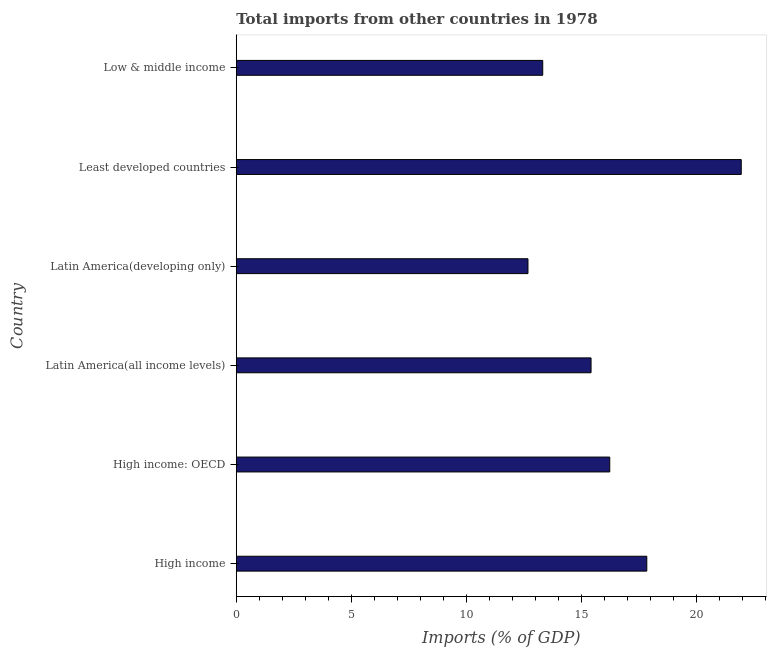Does the graph contain grids?
Offer a terse response. No. What is the title of the graph?
Offer a terse response. Total imports from other countries in 1978. What is the label or title of the X-axis?
Your answer should be very brief. Imports (% of GDP). What is the label or title of the Y-axis?
Your answer should be very brief. Country. What is the total imports in High income?
Your answer should be very brief. 17.84. Across all countries, what is the maximum total imports?
Offer a very short reply. 21.95. Across all countries, what is the minimum total imports?
Your answer should be compact. 12.68. In which country was the total imports maximum?
Make the answer very short. Least developed countries. In which country was the total imports minimum?
Give a very brief answer. Latin America(developing only). What is the sum of the total imports?
Provide a short and direct response. 97.45. What is the difference between the total imports in High income: OECD and Low & middle income?
Your answer should be very brief. 2.91. What is the average total imports per country?
Offer a very short reply. 16.24. What is the median total imports?
Offer a very short reply. 15.83. In how many countries, is the total imports greater than 13 %?
Your answer should be very brief. 5. What is the ratio of the total imports in Latin America(all income levels) to that in Latin America(developing only)?
Ensure brevity in your answer.  1.22. Is the difference between the total imports in High income: OECD and Least developed countries greater than the difference between any two countries?
Give a very brief answer. No. What is the difference between the highest and the second highest total imports?
Give a very brief answer. 4.11. What is the difference between the highest and the lowest total imports?
Keep it short and to the point. 9.27. In how many countries, is the total imports greater than the average total imports taken over all countries?
Your response must be concise. 2. How many countries are there in the graph?
Provide a succinct answer. 6. What is the Imports (% of GDP) of High income?
Offer a very short reply. 17.84. What is the Imports (% of GDP) in High income: OECD?
Provide a succinct answer. 16.23. What is the Imports (% of GDP) of Latin America(all income levels)?
Provide a succinct answer. 15.42. What is the Imports (% of GDP) in Latin America(developing only)?
Make the answer very short. 12.68. What is the Imports (% of GDP) of Least developed countries?
Keep it short and to the point. 21.95. What is the Imports (% of GDP) of Low & middle income?
Offer a terse response. 13.32. What is the difference between the Imports (% of GDP) in High income and High income: OECD?
Give a very brief answer. 1.61. What is the difference between the Imports (% of GDP) in High income and Latin America(all income levels)?
Ensure brevity in your answer.  2.42. What is the difference between the Imports (% of GDP) in High income and Latin America(developing only)?
Provide a succinct answer. 5.16. What is the difference between the Imports (% of GDP) in High income and Least developed countries?
Provide a succinct answer. -4.1. What is the difference between the Imports (% of GDP) in High income and Low & middle income?
Your answer should be very brief. 4.52. What is the difference between the Imports (% of GDP) in High income: OECD and Latin America(all income levels)?
Make the answer very short. 0.81. What is the difference between the Imports (% of GDP) in High income: OECD and Latin America(developing only)?
Provide a succinct answer. 3.55. What is the difference between the Imports (% of GDP) in High income: OECD and Least developed countries?
Your answer should be very brief. -5.72. What is the difference between the Imports (% of GDP) in High income: OECD and Low & middle income?
Ensure brevity in your answer.  2.91. What is the difference between the Imports (% of GDP) in Latin America(all income levels) and Latin America(developing only)?
Your answer should be compact. 2.74. What is the difference between the Imports (% of GDP) in Latin America(all income levels) and Least developed countries?
Offer a terse response. -6.53. What is the difference between the Imports (% of GDP) in Latin America(all income levels) and Low & middle income?
Your answer should be very brief. 2.1. What is the difference between the Imports (% of GDP) in Latin America(developing only) and Least developed countries?
Offer a very short reply. -9.27. What is the difference between the Imports (% of GDP) in Latin America(developing only) and Low & middle income?
Provide a short and direct response. -0.64. What is the difference between the Imports (% of GDP) in Least developed countries and Low & middle income?
Ensure brevity in your answer.  8.63. What is the ratio of the Imports (% of GDP) in High income to that in High income: OECD?
Keep it short and to the point. 1.1. What is the ratio of the Imports (% of GDP) in High income to that in Latin America(all income levels)?
Your response must be concise. 1.16. What is the ratio of the Imports (% of GDP) in High income to that in Latin America(developing only)?
Provide a succinct answer. 1.41. What is the ratio of the Imports (% of GDP) in High income to that in Least developed countries?
Provide a short and direct response. 0.81. What is the ratio of the Imports (% of GDP) in High income to that in Low & middle income?
Ensure brevity in your answer.  1.34. What is the ratio of the Imports (% of GDP) in High income: OECD to that in Latin America(all income levels)?
Offer a terse response. 1.05. What is the ratio of the Imports (% of GDP) in High income: OECD to that in Latin America(developing only)?
Your answer should be very brief. 1.28. What is the ratio of the Imports (% of GDP) in High income: OECD to that in Least developed countries?
Provide a short and direct response. 0.74. What is the ratio of the Imports (% of GDP) in High income: OECD to that in Low & middle income?
Give a very brief answer. 1.22. What is the ratio of the Imports (% of GDP) in Latin America(all income levels) to that in Latin America(developing only)?
Your answer should be very brief. 1.22. What is the ratio of the Imports (% of GDP) in Latin America(all income levels) to that in Least developed countries?
Your answer should be very brief. 0.7. What is the ratio of the Imports (% of GDP) in Latin America(all income levels) to that in Low & middle income?
Provide a succinct answer. 1.16. What is the ratio of the Imports (% of GDP) in Latin America(developing only) to that in Least developed countries?
Make the answer very short. 0.58. What is the ratio of the Imports (% of GDP) in Least developed countries to that in Low & middle income?
Your answer should be compact. 1.65. 